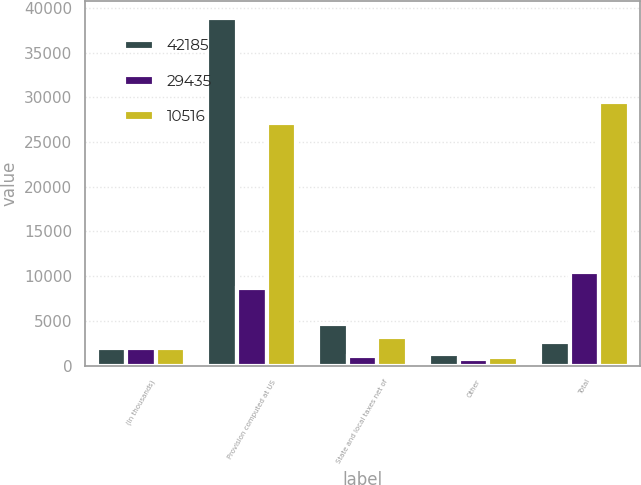Convert chart. <chart><loc_0><loc_0><loc_500><loc_500><stacked_bar_chart><ecel><fcel>(In thousands)<fcel>Provision computed at US<fcel>State and local taxes net of<fcel>Other<fcel>Total<nl><fcel>42185<fcel>2004<fcel>38820<fcel>4666<fcel>1301<fcel>2612.5<nl><fcel>29435<fcel>2003<fcel>8711<fcel>1018<fcel>787<fcel>10516<nl><fcel>10516<fcel>2002<fcel>27165<fcel>3221<fcel>951<fcel>29435<nl></chart> 